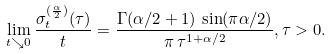<formula> <loc_0><loc_0><loc_500><loc_500>\lim _ { t \searrow 0 } \frac { \sigma _ { t } ^ { ( \frac { \alpha } { 2 } ) } ( \tau ) } { t } = \frac { \Gamma ( \alpha / 2 + 1 ) \, \sin ( \pi \alpha / 2 ) } { \pi \, \tau ^ { 1 + \alpha / 2 } } , \tau > 0 .</formula> 